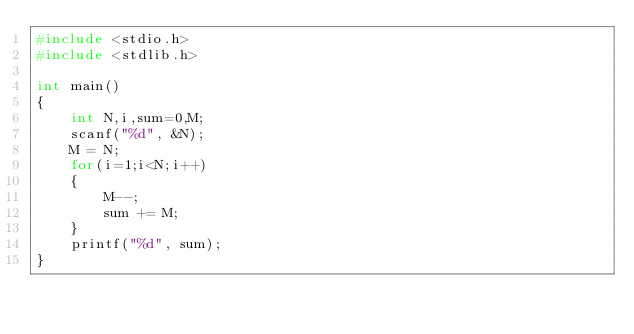Convert code to text. <code><loc_0><loc_0><loc_500><loc_500><_C_>#include <stdio.h>
#include <stdlib.h>

int main()
{
    int N,i,sum=0,M;
    scanf("%d", &N);
    M = N;
    for(i=1;i<N;i++)
    {
    	M--;
    	sum += M;
    }
    printf("%d", sum);
}
</code> 